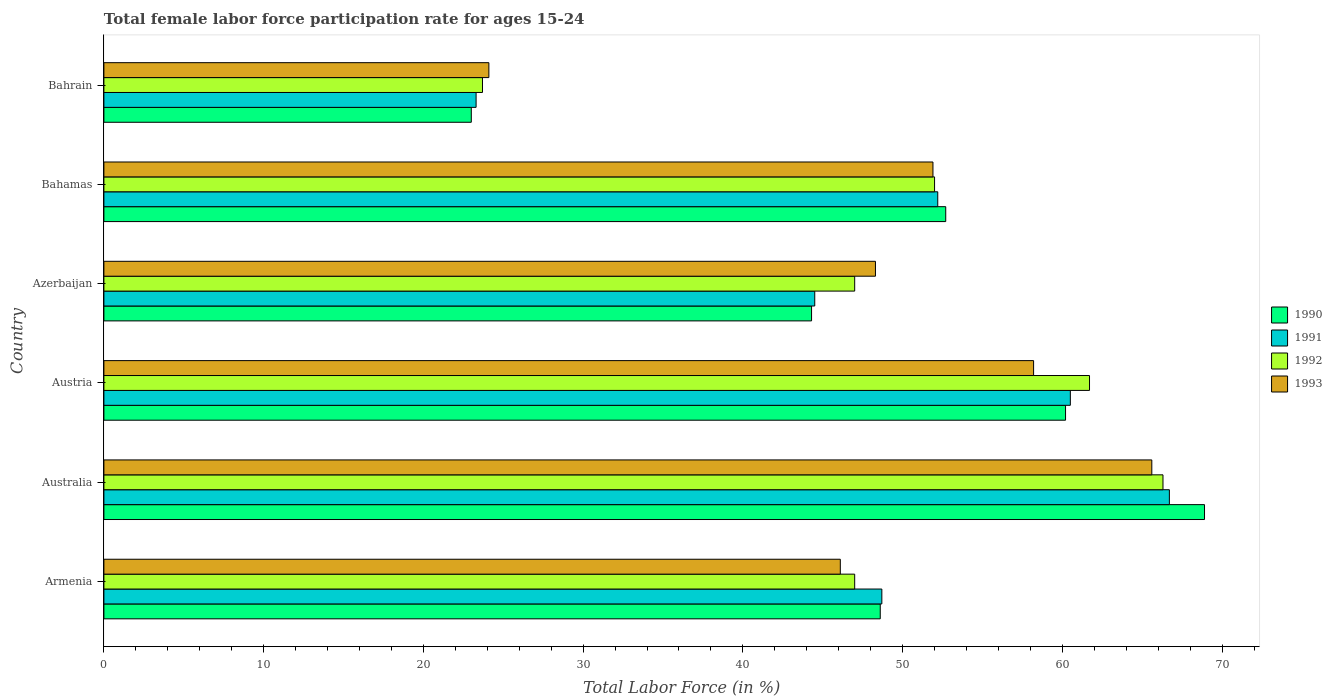How many different coloured bars are there?
Provide a succinct answer. 4. How many groups of bars are there?
Keep it short and to the point. 6. Are the number of bars per tick equal to the number of legend labels?
Your response must be concise. Yes. Are the number of bars on each tick of the Y-axis equal?
Your response must be concise. Yes. How many bars are there on the 6th tick from the top?
Your answer should be very brief. 4. What is the label of the 2nd group of bars from the top?
Offer a terse response. Bahamas. In how many cases, is the number of bars for a given country not equal to the number of legend labels?
Ensure brevity in your answer.  0. What is the female labor force participation rate in 1992 in Australia?
Make the answer very short. 66.3. Across all countries, what is the maximum female labor force participation rate in 1992?
Your answer should be very brief. 66.3. Across all countries, what is the minimum female labor force participation rate in 1992?
Provide a succinct answer. 23.7. In which country was the female labor force participation rate in 1992 minimum?
Provide a succinct answer. Bahrain. What is the total female labor force participation rate in 1991 in the graph?
Give a very brief answer. 295.9. What is the difference between the female labor force participation rate in 1990 in Armenia and that in Bahrain?
Make the answer very short. 25.6. What is the difference between the female labor force participation rate in 1990 in Bahrain and the female labor force participation rate in 1993 in Australia?
Offer a terse response. -42.6. What is the average female labor force participation rate in 1991 per country?
Keep it short and to the point. 49.32. In how many countries, is the female labor force participation rate in 1993 greater than 44 %?
Provide a succinct answer. 5. What is the ratio of the female labor force participation rate in 1990 in Australia to that in Austria?
Your answer should be very brief. 1.14. Is the difference between the female labor force participation rate in 1993 in Armenia and Bahamas greater than the difference between the female labor force participation rate in 1992 in Armenia and Bahamas?
Provide a short and direct response. No. What is the difference between the highest and the second highest female labor force participation rate in 1991?
Provide a succinct answer. 6.2. What is the difference between the highest and the lowest female labor force participation rate in 1990?
Your response must be concise. 45.9. In how many countries, is the female labor force participation rate in 1991 greater than the average female labor force participation rate in 1991 taken over all countries?
Offer a very short reply. 3. What does the 2nd bar from the top in Austria represents?
Offer a very short reply. 1992. How many bars are there?
Provide a succinct answer. 24. Are all the bars in the graph horizontal?
Your response must be concise. Yes. Does the graph contain grids?
Offer a very short reply. No. How many legend labels are there?
Provide a short and direct response. 4. What is the title of the graph?
Ensure brevity in your answer.  Total female labor force participation rate for ages 15-24. What is the label or title of the Y-axis?
Your response must be concise. Country. What is the Total Labor Force (in %) in 1990 in Armenia?
Provide a short and direct response. 48.6. What is the Total Labor Force (in %) of 1991 in Armenia?
Make the answer very short. 48.7. What is the Total Labor Force (in %) in 1992 in Armenia?
Offer a very short reply. 47. What is the Total Labor Force (in %) in 1993 in Armenia?
Make the answer very short. 46.1. What is the Total Labor Force (in %) in 1990 in Australia?
Your answer should be very brief. 68.9. What is the Total Labor Force (in %) in 1991 in Australia?
Your response must be concise. 66.7. What is the Total Labor Force (in %) in 1992 in Australia?
Provide a short and direct response. 66.3. What is the Total Labor Force (in %) of 1993 in Australia?
Your response must be concise. 65.6. What is the Total Labor Force (in %) of 1990 in Austria?
Offer a terse response. 60.2. What is the Total Labor Force (in %) in 1991 in Austria?
Make the answer very short. 60.5. What is the Total Labor Force (in %) of 1992 in Austria?
Ensure brevity in your answer.  61.7. What is the Total Labor Force (in %) of 1993 in Austria?
Provide a short and direct response. 58.2. What is the Total Labor Force (in %) of 1990 in Azerbaijan?
Give a very brief answer. 44.3. What is the Total Labor Force (in %) in 1991 in Azerbaijan?
Your answer should be compact. 44.5. What is the Total Labor Force (in %) of 1992 in Azerbaijan?
Your response must be concise. 47. What is the Total Labor Force (in %) of 1993 in Azerbaijan?
Offer a terse response. 48.3. What is the Total Labor Force (in %) in 1990 in Bahamas?
Offer a terse response. 52.7. What is the Total Labor Force (in %) in 1991 in Bahamas?
Provide a succinct answer. 52.2. What is the Total Labor Force (in %) of 1993 in Bahamas?
Make the answer very short. 51.9. What is the Total Labor Force (in %) in 1991 in Bahrain?
Provide a succinct answer. 23.3. What is the Total Labor Force (in %) in 1992 in Bahrain?
Offer a terse response. 23.7. What is the Total Labor Force (in %) of 1993 in Bahrain?
Your answer should be compact. 24.1. Across all countries, what is the maximum Total Labor Force (in %) in 1990?
Provide a succinct answer. 68.9. Across all countries, what is the maximum Total Labor Force (in %) of 1991?
Your response must be concise. 66.7. Across all countries, what is the maximum Total Labor Force (in %) in 1992?
Your answer should be very brief. 66.3. Across all countries, what is the maximum Total Labor Force (in %) of 1993?
Give a very brief answer. 65.6. Across all countries, what is the minimum Total Labor Force (in %) of 1991?
Offer a very short reply. 23.3. Across all countries, what is the minimum Total Labor Force (in %) in 1992?
Ensure brevity in your answer.  23.7. Across all countries, what is the minimum Total Labor Force (in %) in 1993?
Make the answer very short. 24.1. What is the total Total Labor Force (in %) in 1990 in the graph?
Provide a succinct answer. 297.7. What is the total Total Labor Force (in %) of 1991 in the graph?
Provide a short and direct response. 295.9. What is the total Total Labor Force (in %) of 1992 in the graph?
Offer a terse response. 297.7. What is the total Total Labor Force (in %) in 1993 in the graph?
Ensure brevity in your answer.  294.2. What is the difference between the Total Labor Force (in %) in 1990 in Armenia and that in Australia?
Your answer should be compact. -20.3. What is the difference between the Total Labor Force (in %) of 1992 in Armenia and that in Australia?
Give a very brief answer. -19.3. What is the difference between the Total Labor Force (in %) in 1993 in Armenia and that in Australia?
Your answer should be very brief. -19.5. What is the difference between the Total Labor Force (in %) of 1992 in Armenia and that in Austria?
Your answer should be very brief. -14.7. What is the difference between the Total Labor Force (in %) of 1993 in Armenia and that in Austria?
Ensure brevity in your answer.  -12.1. What is the difference between the Total Labor Force (in %) in 1990 in Armenia and that in Bahamas?
Your answer should be compact. -4.1. What is the difference between the Total Labor Force (in %) of 1992 in Armenia and that in Bahamas?
Your response must be concise. -5. What is the difference between the Total Labor Force (in %) in 1993 in Armenia and that in Bahamas?
Provide a succinct answer. -5.8. What is the difference between the Total Labor Force (in %) of 1990 in Armenia and that in Bahrain?
Make the answer very short. 25.6. What is the difference between the Total Labor Force (in %) of 1991 in Armenia and that in Bahrain?
Keep it short and to the point. 25.4. What is the difference between the Total Labor Force (in %) in 1992 in Armenia and that in Bahrain?
Ensure brevity in your answer.  23.3. What is the difference between the Total Labor Force (in %) of 1993 in Armenia and that in Bahrain?
Offer a terse response. 22. What is the difference between the Total Labor Force (in %) of 1991 in Australia and that in Austria?
Provide a short and direct response. 6.2. What is the difference between the Total Labor Force (in %) in 1993 in Australia and that in Austria?
Your response must be concise. 7.4. What is the difference between the Total Labor Force (in %) of 1990 in Australia and that in Azerbaijan?
Your response must be concise. 24.6. What is the difference between the Total Labor Force (in %) of 1991 in Australia and that in Azerbaijan?
Give a very brief answer. 22.2. What is the difference between the Total Labor Force (in %) of 1992 in Australia and that in Azerbaijan?
Ensure brevity in your answer.  19.3. What is the difference between the Total Labor Force (in %) in 1990 in Australia and that in Bahrain?
Provide a short and direct response. 45.9. What is the difference between the Total Labor Force (in %) in 1991 in Australia and that in Bahrain?
Offer a very short reply. 43.4. What is the difference between the Total Labor Force (in %) of 1992 in Australia and that in Bahrain?
Make the answer very short. 42.6. What is the difference between the Total Labor Force (in %) in 1993 in Australia and that in Bahrain?
Offer a very short reply. 41.5. What is the difference between the Total Labor Force (in %) of 1990 in Austria and that in Azerbaijan?
Provide a short and direct response. 15.9. What is the difference between the Total Labor Force (in %) in 1992 in Austria and that in Azerbaijan?
Provide a short and direct response. 14.7. What is the difference between the Total Labor Force (in %) in 1993 in Austria and that in Azerbaijan?
Provide a short and direct response. 9.9. What is the difference between the Total Labor Force (in %) in 1990 in Austria and that in Bahamas?
Your response must be concise. 7.5. What is the difference between the Total Labor Force (in %) of 1991 in Austria and that in Bahamas?
Make the answer very short. 8.3. What is the difference between the Total Labor Force (in %) of 1990 in Austria and that in Bahrain?
Your answer should be compact. 37.2. What is the difference between the Total Labor Force (in %) of 1991 in Austria and that in Bahrain?
Ensure brevity in your answer.  37.2. What is the difference between the Total Labor Force (in %) in 1992 in Austria and that in Bahrain?
Provide a succinct answer. 38. What is the difference between the Total Labor Force (in %) in 1993 in Austria and that in Bahrain?
Make the answer very short. 34.1. What is the difference between the Total Labor Force (in %) of 1991 in Azerbaijan and that in Bahamas?
Provide a succinct answer. -7.7. What is the difference between the Total Labor Force (in %) of 1993 in Azerbaijan and that in Bahamas?
Provide a short and direct response. -3.6. What is the difference between the Total Labor Force (in %) in 1990 in Azerbaijan and that in Bahrain?
Make the answer very short. 21.3. What is the difference between the Total Labor Force (in %) in 1991 in Azerbaijan and that in Bahrain?
Your answer should be compact. 21.2. What is the difference between the Total Labor Force (in %) of 1992 in Azerbaijan and that in Bahrain?
Provide a succinct answer. 23.3. What is the difference between the Total Labor Force (in %) of 1993 in Azerbaijan and that in Bahrain?
Ensure brevity in your answer.  24.2. What is the difference between the Total Labor Force (in %) of 1990 in Bahamas and that in Bahrain?
Your answer should be very brief. 29.7. What is the difference between the Total Labor Force (in %) in 1991 in Bahamas and that in Bahrain?
Make the answer very short. 28.9. What is the difference between the Total Labor Force (in %) of 1992 in Bahamas and that in Bahrain?
Your response must be concise. 28.3. What is the difference between the Total Labor Force (in %) in 1993 in Bahamas and that in Bahrain?
Your answer should be very brief. 27.8. What is the difference between the Total Labor Force (in %) of 1990 in Armenia and the Total Labor Force (in %) of 1991 in Australia?
Your answer should be very brief. -18.1. What is the difference between the Total Labor Force (in %) of 1990 in Armenia and the Total Labor Force (in %) of 1992 in Australia?
Provide a succinct answer. -17.7. What is the difference between the Total Labor Force (in %) in 1990 in Armenia and the Total Labor Force (in %) in 1993 in Australia?
Ensure brevity in your answer.  -17. What is the difference between the Total Labor Force (in %) of 1991 in Armenia and the Total Labor Force (in %) of 1992 in Australia?
Provide a short and direct response. -17.6. What is the difference between the Total Labor Force (in %) in 1991 in Armenia and the Total Labor Force (in %) in 1993 in Australia?
Keep it short and to the point. -16.9. What is the difference between the Total Labor Force (in %) of 1992 in Armenia and the Total Labor Force (in %) of 1993 in Australia?
Keep it short and to the point. -18.6. What is the difference between the Total Labor Force (in %) of 1991 in Armenia and the Total Labor Force (in %) of 1992 in Austria?
Provide a succinct answer. -13. What is the difference between the Total Labor Force (in %) of 1991 in Armenia and the Total Labor Force (in %) of 1993 in Austria?
Your answer should be very brief. -9.5. What is the difference between the Total Labor Force (in %) of 1992 in Armenia and the Total Labor Force (in %) of 1993 in Austria?
Give a very brief answer. -11.2. What is the difference between the Total Labor Force (in %) of 1992 in Armenia and the Total Labor Force (in %) of 1993 in Azerbaijan?
Your response must be concise. -1.3. What is the difference between the Total Labor Force (in %) of 1990 in Armenia and the Total Labor Force (in %) of 1991 in Bahamas?
Keep it short and to the point. -3.6. What is the difference between the Total Labor Force (in %) in 1990 in Armenia and the Total Labor Force (in %) in 1992 in Bahamas?
Provide a short and direct response. -3.4. What is the difference between the Total Labor Force (in %) of 1991 in Armenia and the Total Labor Force (in %) of 1992 in Bahamas?
Keep it short and to the point. -3.3. What is the difference between the Total Labor Force (in %) of 1990 in Armenia and the Total Labor Force (in %) of 1991 in Bahrain?
Keep it short and to the point. 25.3. What is the difference between the Total Labor Force (in %) in 1990 in Armenia and the Total Labor Force (in %) in 1992 in Bahrain?
Offer a terse response. 24.9. What is the difference between the Total Labor Force (in %) of 1991 in Armenia and the Total Labor Force (in %) of 1992 in Bahrain?
Ensure brevity in your answer.  25. What is the difference between the Total Labor Force (in %) in 1991 in Armenia and the Total Labor Force (in %) in 1993 in Bahrain?
Provide a short and direct response. 24.6. What is the difference between the Total Labor Force (in %) of 1992 in Armenia and the Total Labor Force (in %) of 1993 in Bahrain?
Make the answer very short. 22.9. What is the difference between the Total Labor Force (in %) in 1990 in Australia and the Total Labor Force (in %) in 1991 in Austria?
Ensure brevity in your answer.  8.4. What is the difference between the Total Labor Force (in %) of 1992 in Australia and the Total Labor Force (in %) of 1993 in Austria?
Offer a terse response. 8.1. What is the difference between the Total Labor Force (in %) of 1990 in Australia and the Total Labor Force (in %) of 1991 in Azerbaijan?
Ensure brevity in your answer.  24.4. What is the difference between the Total Labor Force (in %) in 1990 in Australia and the Total Labor Force (in %) in 1992 in Azerbaijan?
Your response must be concise. 21.9. What is the difference between the Total Labor Force (in %) of 1990 in Australia and the Total Labor Force (in %) of 1993 in Azerbaijan?
Offer a terse response. 20.6. What is the difference between the Total Labor Force (in %) of 1991 in Australia and the Total Labor Force (in %) of 1992 in Azerbaijan?
Provide a succinct answer. 19.7. What is the difference between the Total Labor Force (in %) in 1992 in Australia and the Total Labor Force (in %) in 1993 in Azerbaijan?
Provide a short and direct response. 18. What is the difference between the Total Labor Force (in %) in 1990 in Australia and the Total Labor Force (in %) in 1992 in Bahamas?
Keep it short and to the point. 16.9. What is the difference between the Total Labor Force (in %) of 1991 in Australia and the Total Labor Force (in %) of 1992 in Bahamas?
Make the answer very short. 14.7. What is the difference between the Total Labor Force (in %) in 1991 in Australia and the Total Labor Force (in %) in 1993 in Bahamas?
Offer a terse response. 14.8. What is the difference between the Total Labor Force (in %) in 1990 in Australia and the Total Labor Force (in %) in 1991 in Bahrain?
Ensure brevity in your answer.  45.6. What is the difference between the Total Labor Force (in %) of 1990 in Australia and the Total Labor Force (in %) of 1992 in Bahrain?
Your answer should be very brief. 45.2. What is the difference between the Total Labor Force (in %) in 1990 in Australia and the Total Labor Force (in %) in 1993 in Bahrain?
Give a very brief answer. 44.8. What is the difference between the Total Labor Force (in %) in 1991 in Australia and the Total Labor Force (in %) in 1993 in Bahrain?
Your answer should be very brief. 42.6. What is the difference between the Total Labor Force (in %) in 1992 in Australia and the Total Labor Force (in %) in 1993 in Bahrain?
Your answer should be compact. 42.2. What is the difference between the Total Labor Force (in %) in 1992 in Austria and the Total Labor Force (in %) in 1993 in Azerbaijan?
Your response must be concise. 13.4. What is the difference between the Total Labor Force (in %) in 1990 in Austria and the Total Labor Force (in %) in 1991 in Bahamas?
Your answer should be compact. 8. What is the difference between the Total Labor Force (in %) of 1991 in Austria and the Total Labor Force (in %) of 1993 in Bahamas?
Provide a short and direct response. 8.6. What is the difference between the Total Labor Force (in %) of 1990 in Austria and the Total Labor Force (in %) of 1991 in Bahrain?
Offer a terse response. 36.9. What is the difference between the Total Labor Force (in %) in 1990 in Austria and the Total Labor Force (in %) in 1992 in Bahrain?
Offer a terse response. 36.5. What is the difference between the Total Labor Force (in %) of 1990 in Austria and the Total Labor Force (in %) of 1993 in Bahrain?
Offer a terse response. 36.1. What is the difference between the Total Labor Force (in %) of 1991 in Austria and the Total Labor Force (in %) of 1992 in Bahrain?
Offer a terse response. 36.8. What is the difference between the Total Labor Force (in %) in 1991 in Austria and the Total Labor Force (in %) in 1993 in Bahrain?
Provide a succinct answer. 36.4. What is the difference between the Total Labor Force (in %) of 1992 in Austria and the Total Labor Force (in %) of 1993 in Bahrain?
Your answer should be very brief. 37.6. What is the difference between the Total Labor Force (in %) of 1990 in Azerbaijan and the Total Labor Force (in %) of 1992 in Bahamas?
Offer a terse response. -7.7. What is the difference between the Total Labor Force (in %) in 1990 in Azerbaijan and the Total Labor Force (in %) in 1993 in Bahamas?
Keep it short and to the point. -7.6. What is the difference between the Total Labor Force (in %) in 1991 in Azerbaijan and the Total Labor Force (in %) in 1993 in Bahamas?
Offer a terse response. -7.4. What is the difference between the Total Labor Force (in %) of 1992 in Azerbaijan and the Total Labor Force (in %) of 1993 in Bahamas?
Your answer should be very brief. -4.9. What is the difference between the Total Labor Force (in %) of 1990 in Azerbaijan and the Total Labor Force (in %) of 1991 in Bahrain?
Offer a very short reply. 21. What is the difference between the Total Labor Force (in %) in 1990 in Azerbaijan and the Total Labor Force (in %) in 1992 in Bahrain?
Your response must be concise. 20.6. What is the difference between the Total Labor Force (in %) in 1990 in Azerbaijan and the Total Labor Force (in %) in 1993 in Bahrain?
Ensure brevity in your answer.  20.2. What is the difference between the Total Labor Force (in %) in 1991 in Azerbaijan and the Total Labor Force (in %) in 1992 in Bahrain?
Your answer should be very brief. 20.8. What is the difference between the Total Labor Force (in %) of 1991 in Azerbaijan and the Total Labor Force (in %) of 1993 in Bahrain?
Make the answer very short. 20.4. What is the difference between the Total Labor Force (in %) of 1992 in Azerbaijan and the Total Labor Force (in %) of 1993 in Bahrain?
Your answer should be very brief. 22.9. What is the difference between the Total Labor Force (in %) in 1990 in Bahamas and the Total Labor Force (in %) in 1991 in Bahrain?
Provide a succinct answer. 29.4. What is the difference between the Total Labor Force (in %) of 1990 in Bahamas and the Total Labor Force (in %) of 1993 in Bahrain?
Your answer should be compact. 28.6. What is the difference between the Total Labor Force (in %) in 1991 in Bahamas and the Total Labor Force (in %) in 1992 in Bahrain?
Your answer should be compact. 28.5. What is the difference between the Total Labor Force (in %) of 1991 in Bahamas and the Total Labor Force (in %) of 1993 in Bahrain?
Offer a terse response. 28.1. What is the difference between the Total Labor Force (in %) of 1992 in Bahamas and the Total Labor Force (in %) of 1993 in Bahrain?
Keep it short and to the point. 27.9. What is the average Total Labor Force (in %) of 1990 per country?
Your answer should be very brief. 49.62. What is the average Total Labor Force (in %) in 1991 per country?
Your answer should be very brief. 49.32. What is the average Total Labor Force (in %) in 1992 per country?
Ensure brevity in your answer.  49.62. What is the average Total Labor Force (in %) in 1993 per country?
Give a very brief answer. 49.03. What is the difference between the Total Labor Force (in %) in 1990 and Total Labor Force (in %) in 1991 in Armenia?
Ensure brevity in your answer.  -0.1. What is the difference between the Total Labor Force (in %) of 1990 and Total Labor Force (in %) of 1992 in Armenia?
Provide a short and direct response. 1.6. What is the difference between the Total Labor Force (in %) in 1990 and Total Labor Force (in %) in 1992 in Australia?
Your answer should be very brief. 2.6. What is the difference between the Total Labor Force (in %) of 1990 and Total Labor Force (in %) of 1993 in Australia?
Keep it short and to the point. 3.3. What is the difference between the Total Labor Force (in %) in 1991 and Total Labor Force (in %) in 1993 in Australia?
Offer a terse response. 1.1. What is the difference between the Total Labor Force (in %) of 1992 and Total Labor Force (in %) of 1993 in Australia?
Keep it short and to the point. 0.7. What is the difference between the Total Labor Force (in %) of 1990 and Total Labor Force (in %) of 1993 in Austria?
Offer a very short reply. 2. What is the difference between the Total Labor Force (in %) in 1991 and Total Labor Force (in %) in 1993 in Austria?
Keep it short and to the point. 2.3. What is the difference between the Total Labor Force (in %) of 1992 and Total Labor Force (in %) of 1993 in Austria?
Offer a very short reply. 3.5. What is the difference between the Total Labor Force (in %) in 1990 and Total Labor Force (in %) in 1991 in Azerbaijan?
Give a very brief answer. -0.2. What is the difference between the Total Labor Force (in %) of 1990 and Total Labor Force (in %) of 1992 in Azerbaijan?
Give a very brief answer. -2.7. What is the difference between the Total Labor Force (in %) of 1990 and Total Labor Force (in %) of 1993 in Azerbaijan?
Give a very brief answer. -4. What is the difference between the Total Labor Force (in %) in 1991 and Total Labor Force (in %) in 1993 in Azerbaijan?
Your answer should be very brief. -3.8. What is the difference between the Total Labor Force (in %) in 1990 and Total Labor Force (in %) in 1991 in Bahamas?
Offer a very short reply. 0.5. What is the difference between the Total Labor Force (in %) in 1991 and Total Labor Force (in %) in 1992 in Bahamas?
Make the answer very short. 0.2. What is the difference between the Total Labor Force (in %) in 1991 and Total Labor Force (in %) in 1993 in Bahamas?
Your answer should be compact. 0.3. What is the difference between the Total Labor Force (in %) in 1991 and Total Labor Force (in %) in 1992 in Bahrain?
Give a very brief answer. -0.4. What is the difference between the Total Labor Force (in %) in 1992 and Total Labor Force (in %) in 1993 in Bahrain?
Your answer should be compact. -0.4. What is the ratio of the Total Labor Force (in %) in 1990 in Armenia to that in Australia?
Your answer should be very brief. 0.71. What is the ratio of the Total Labor Force (in %) in 1991 in Armenia to that in Australia?
Offer a terse response. 0.73. What is the ratio of the Total Labor Force (in %) in 1992 in Armenia to that in Australia?
Offer a very short reply. 0.71. What is the ratio of the Total Labor Force (in %) in 1993 in Armenia to that in Australia?
Provide a succinct answer. 0.7. What is the ratio of the Total Labor Force (in %) of 1990 in Armenia to that in Austria?
Offer a terse response. 0.81. What is the ratio of the Total Labor Force (in %) in 1991 in Armenia to that in Austria?
Your answer should be compact. 0.81. What is the ratio of the Total Labor Force (in %) in 1992 in Armenia to that in Austria?
Provide a short and direct response. 0.76. What is the ratio of the Total Labor Force (in %) of 1993 in Armenia to that in Austria?
Offer a very short reply. 0.79. What is the ratio of the Total Labor Force (in %) of 1990 in Armenia to that in Azerbaijan?
Offer a terse response. 1.1. What is the ratio of the Total Labor Force (in %) in 1991 in Armenia to that in Azerbaijan?
Provide a short and direct response. 1.09. What is the ratio of the Total Labor Force (in %) in 1992 in Armenia to that in Azerbaijan?
Provide a short and direct response. 1. What is the ratio of the Total Labor Force (in %) in 1993 in Armenia to that in Azerbaijan?
Provide a short and direct response. 0.95. What is the ratio of the Total Labor Force (in %) in 1990 in Armenia to that in Bahamas?
Provide a short and direct response. 0.92. What is the ratio of the Total Labor Force (in %) in 1991 in Armenia to that in Bahamas?
Provide a short and direct response. 0.93. What is the ratio of the Total Labor Force (in %) of 1992 in Armenia to that in Bahamas?
Provide a short and direct response. 0.9. What is the ratio of the Total Labor Force (in %) of 1993 in Armenia to that in Bahamas?
Offer a terse response. 0.89. What is the ratio of the Total Labor Force (in %) in 1990 in Armenia to that in Bahrain?
Ensure brevity in your answer.  2.11. What is the ratio of the Total Labor Force (in %) of 1991 in Armenia to that in Bahrain?
Your response must be concise. 2.09. What is the ratio of the Total Labor Force (in %) in 1992 in Armenia to that in Bahrain?
Ensure brevity in your answer.  1.98. What is the ratio of the Total Labor Force (in %) of 1993 in Armenia to that in Bahrain?
Offer a terse response. 1.91. What is the ratio of the Total Labor Force (in %) in 1990 in Australia to that in Austria?
Provide a succinct answer. 1.14. What is the ratio of the Total Labor Force (in %) of 1991 in Australia to that in Austria?
Make the answer very short. 1.1. What is the ratio of the Total Labor Force (in %) in 1992 in Australia to that in Austria?
Your response must be concise. 1.07. What is the ratio of the Total Labor Force (in %) of 1993 in Australia to that in Austria?
Give a very brief answer. 1.13. What is the ratio of the Total Labor Force (in %) in 1990 in Australia to that in Azerbaijan?
Your answer should be compact. 1.56. What is the ratio of the Total Labor Force (in %) in 1991 in Australia to that in Azerbaijan?
Your response must be concise. 1.5. What is the ratio of the Total Labor Force (in %) in 1992 in Australia to that in Azerbaijan?
Your answer should be compact. 1.41. What is the ratio of the Total Labor Force (in %) of 1993 in Australia to that in Azerbaijan?
Make the answer very short. 1.36. What is the ratio of the Total Labor Force (in %) of 1990 in Australia to that in Bahamas?
Keep it short and to the point. 1.31. What is the ratio of the Total Labor Force (in %) of 1991 in Australia to that in Bahamas?
Offer a terse response. 1.28. What is the ratio of the Total Labor Force (in %) in 1992 in Australia to that in Bahamas?
Keep it short and to the point. 1.27. What is the ratio of the Total Labor Force (in %) in 1993 in Australia to that in Bahamas?
Provide a succinct answer. 1.26. What is the ratio of the Total Labor Force (in %) of 1990 in Australia to that in Bahrain?
Provide a short and direct response. 3. What is the ratio of the Total Labor Force (in %) in 1991 in Australia to that in Bahrain?
Provide a succinct answer. 2.86. What is the ratio of the Total Labor Force (in %) in 1992 in Australia to that in Bahrain?
Provide a short and direct response. 2.8. What is the ratio of the Total Labor Force (in %) of 1993 in Australia to that in Bahrain?
Keep it short and to the point. 2.72. What is the ratio of the Total Labor Force (in %) in 1990 in Austria to that in Azerbaijan?
Keep it short and to the point. 1.36. What is the ratio of the Total Labor Force (in %) in 1991 in Austria to that in Azerbaijan?
Give a very brief answer. 1.36. What is the ratio of the Total Labor Force (in %) in 1992 in Austria to that in Azerbaijan?
Offer a very short reply. 1.31. What is the ratio of the Total Labor Force (in %) of 1993 in Austria to that in Azerbaijan?
Your answer should be very brief. 1.21. What is the ratio of the Total Labor Force (in %) of 1990 in Austria to that in Bahamas?
Ensure brevity in your answer.  1.14. What is the ratio of the Total Labor Force (in %) in 1991 in Austria to that in Bahamas?
Offer a terse response. 1.16. What is the ratio of the Total Labor Force (in %) of 1992 in Austria to that in Bahamas?
Offer a terse response. 1.19. What is the ratio of the Total Labor Force (in %) in 1993 in Austria to that in Bahamas?
Make the answer very short. 1.12. What is the ratio of the Total Labor Force (in %) in 1990 in Austria to that in Bahrain?
Offer a terse response. 2.62. What is the ratio of the Total Labor Force (in %) of 1991 in Austria to that in Bahrain?
Offer a terse response. 2.6. What is the ratio of the Total Labor Force (in %) in 1992 in Austria to that in Bahrain?
Give a very brief answer. 2.6. What is the ratio of the Total Labor Force (in %) in 1993 in Austria to that in Bahrain?
Ensure brevity in your answer.  2.41. What is the ratio of the Total Labor Force (in %) in 1990 in Azerbaijan to that in Bahamas?
Provide a succinct answer. 0.84. What is the ratio of the Total Labor Force (in %) of 1991 in Azerbaijan to that in Bahamas?
Make the answer very short. 0.85. What is the ratio of the Total Labor Force (in %) of 1992 in Azerbaijan to that in Bahamas?
Provide a succinct answer. 0.9. What is the ratio of the Total Labor Force (in %) of 1993 in Azerbaijan to that in Bahamas?
Offer a very short reply. 0.93. What is the ratio of the Total Labor Force (in %) of 1990 in Azerbaijan to that in Bahrain?
Make the answer very short. 1.93. What is the ratio of the Total Labor Force (in %) in 1991 in Azerbaijan to that in Bahrain?
Your answer should be very brief. 1.91. What is the ratio of the Total Labor Force (in %) in 1992 in Azerbaijan to that in Bahrain?
Offer a terse response. 1.98. What is the ratio of the Total Labor Force (in %) in 1993 in Azerbaijan to that in Bahrain?
Your answer should be very brief. 2. What is the ratio of the Total Labor Force (in %) in 1990 in Bahamas to that in Bahrain?
Make the answer very short. 2.29. What is the ratio of the Total Labor Force (in %) of 1991 in Bahamas to that in Bahrain?
Offer a very short reply. 2.24. What is the ratio of the Total Labor Force (in %) of 1992 in Bahamas to that in Bahrain?
Make the answer very short. 2.19. What is the ratio of the Total Labor Force (in %) of 1993 in Bahamas to that in Bahrain?
Your answer should be very brief. 2.15. What is the difference between the highest and the second highest Total Labor Force (in %) of 1991?
Your answer should be compact. 6.2. What is the difference between the highest and the lowest Total Labor Force (in %) of 1990?
Your response must be concise. 45.9. What is the difference between the highest and the lowest Total Labor Force (in %) in 1991?
Keep it short and to the point. 43.4. What is the difference between the highest and the lowest Total Labor Force (in %) in 1992?
Your answer should be very brief. 42.6. What is the difference between the highest and the lowest Total Labor Force (in %) in 1993?
Make the answer very short. 41.5. 